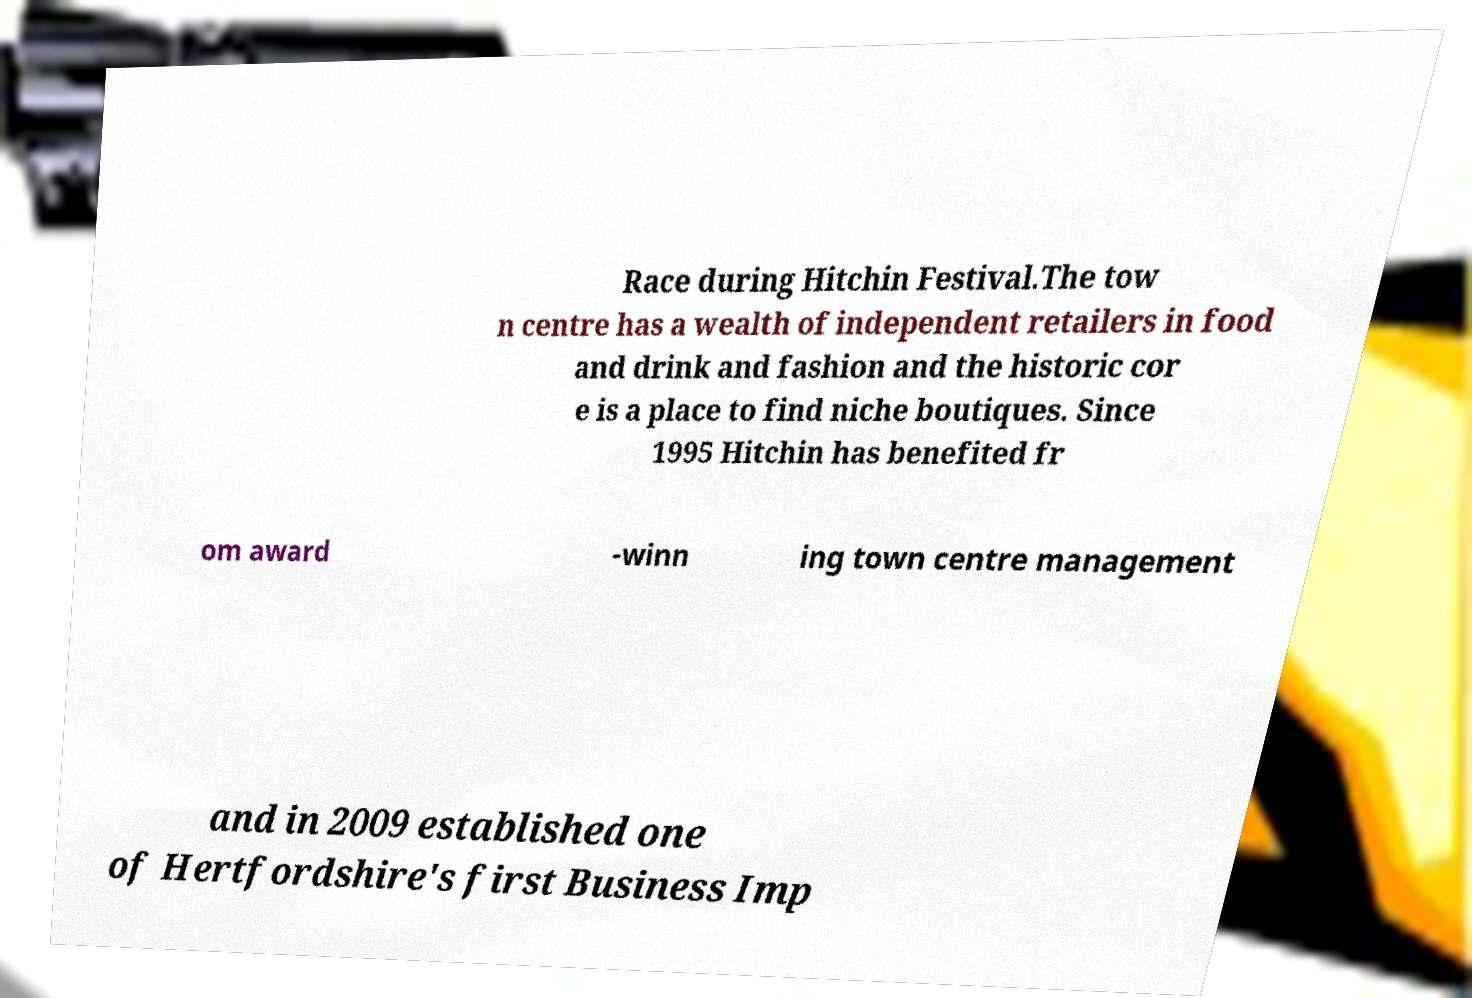Please read and relay the text visible in this image. What does it say? Race during Hitchin Festival.The tow n centre has a wealth of independent retailers in food and drink and fashion and the historic cor e is a place to find niche boutiques. Since 1995 Hitchin has benefited fr om award -winn ing town centre management and in 2009 established one of Hertfordshire's first Business Imp 